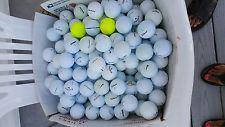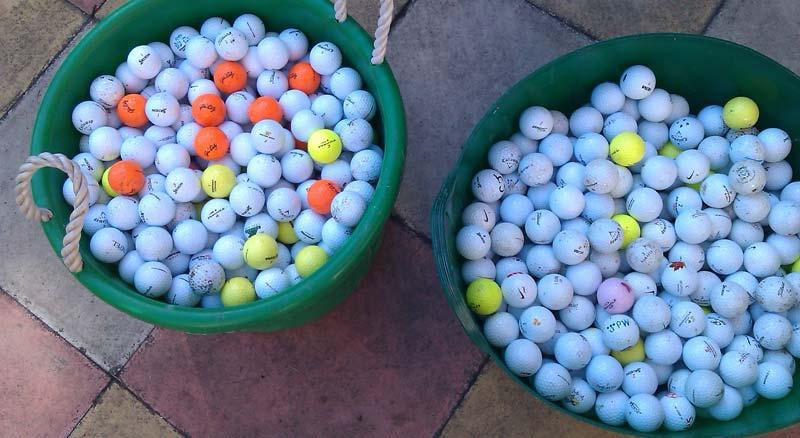The first image is the image on the left, the second image is the image on the right. Evaluate the accuracy of this statement regarding the images: "A collection of golf balls includes at least one bright orange ball, in one image.". Is it true? Answer yes or no. Yes. 